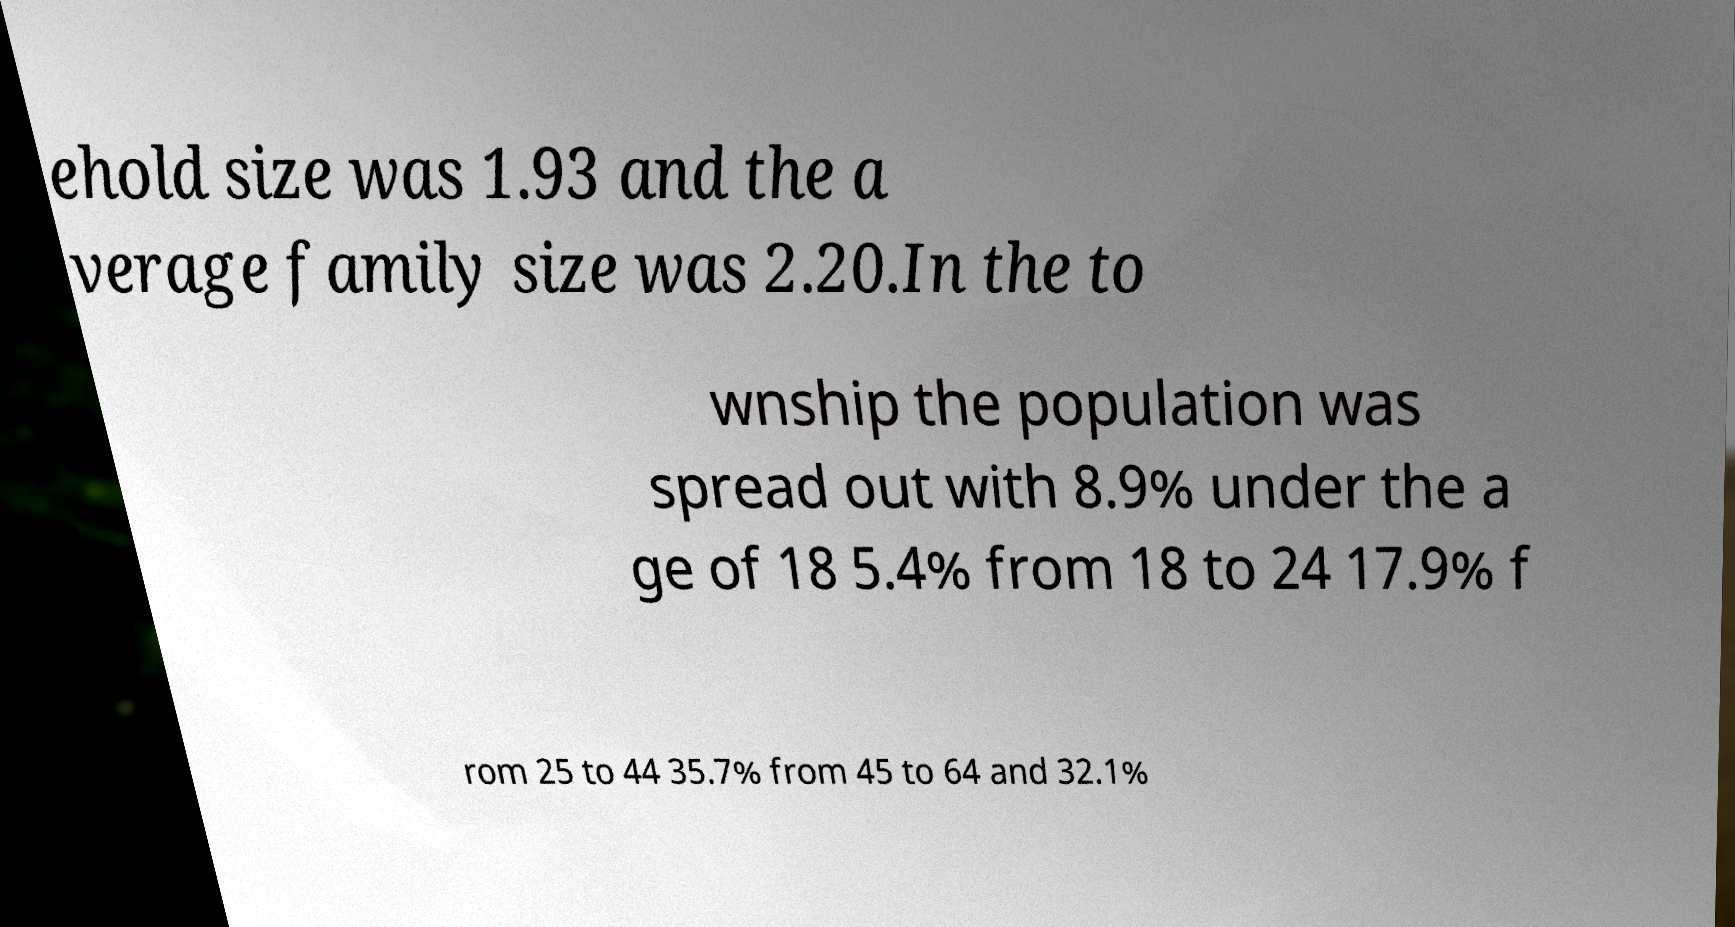Can you accurately transcribe the text from the provided image for me? ehold size was 1.93 and the a verage family size was 2.20.In the to wnship the population was spread out with 8.9% under the a ge of 18 5.4% from 18 to 24 17.9% f rom 25 to 44 35.7% from 45 to 64 and 32.1% 